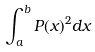Convert formula to latex. <formula><loc_0><loc_0><loc_500><loc_500>\int _ { a } ^ { b } P ( x ) ^ { 2 } d x</formula> 